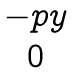<formula> <loc_0><loc_0><loc_500><loc_500>\begin{matrix} - p y \\ 0 \end{matrix}</formula> 